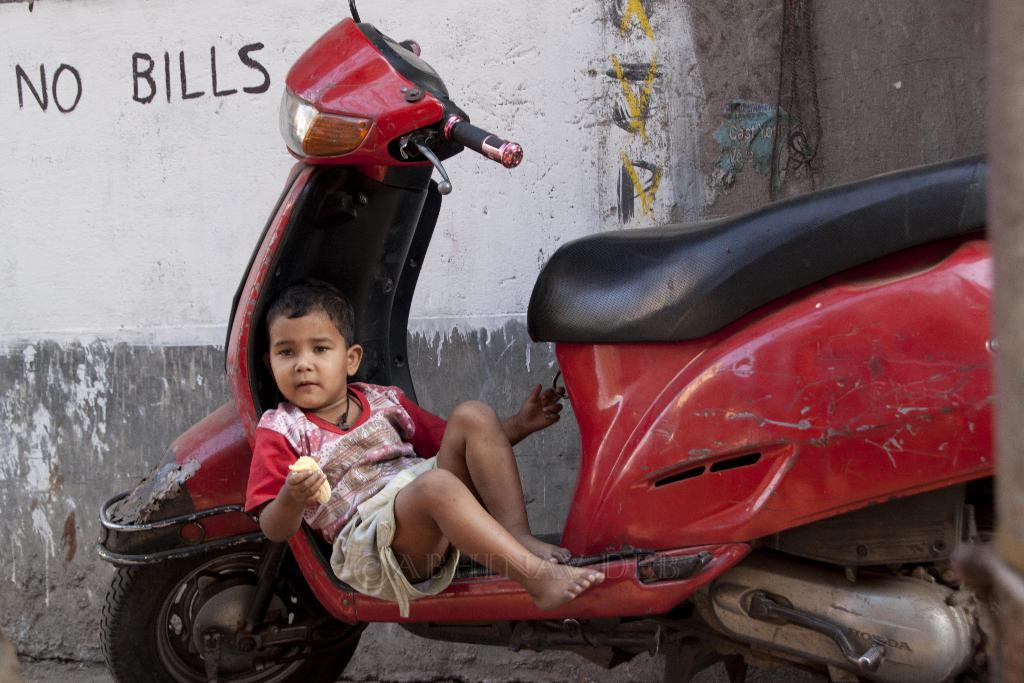What vehicle is present in the image? There is a scooter in the image. Who is on the scooter? A boy is sitting on the scooter. What is the boy holding in his hand? The boy is holding something in his hand. What can be seen in the background of the image? There is a wall in the image. What is written on the wall? There is writing on the wall. What type of star can be seen shining brightly in the image? There is no star visible in the image; it is focused on a scooter, a boy, and a wall with writing. 